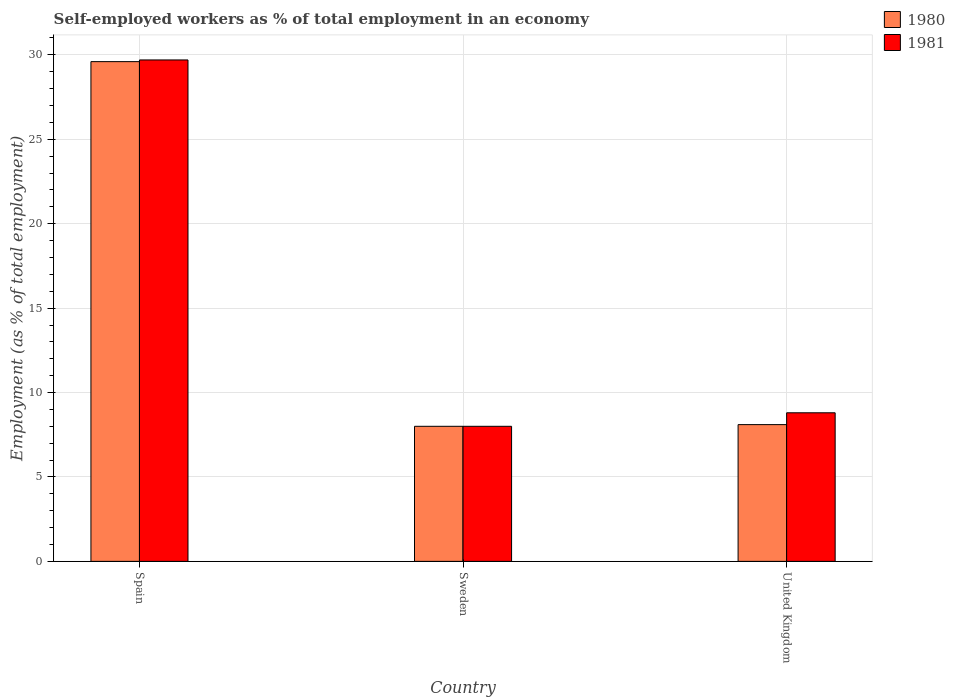Are the number of bars on each tick of the X-axis equal?
Offer a very short reply. Yes. How many bars are there on the 3rd tick from the left?
Your answer should be very brief. 2. What is the label of the 3rd group of bars from the left?
Offer a terse response. United Kingdom. What is the percentage of self-employed workers in 1981 in Spain?
Make the answer very short. 29.7. Across all countries, what is the maximum percentage of self-employed workers in 1980?
Give a very brief answer. 29.6. In which country was the percentage of self-employed workers in 1981 maximum?
Provide a short and direct response. Spain. In which country was the percentage of self-employed workers in 1980 minimum?
Make the answer very short. Sweden. What is the total percentage of self-employed workers in 1980 in the graph?
Your answer should be very brief. 45.7. What is the difference between the percentage of self-employed workers in 1981 in Sweden and that in United Kingdom?
Make the answer very short. -0.8. What is the difference between the percentage of self-employed workers in 1980 in Sweden and the percentage of self-employed workers in 1981 in United Kingdom?
Keep it short and to the point. -0.8. What is the average percentage of self-employed workers in 1980 per country?
Offer a terse response. 15.23. What is the difference between the percentage of self-employed workers of/in 1981 and percentage of self-employed workers of/in 1980 in United Kingdom?
Your response must be concise. 0.7. In how many countries, is the percentage of self-employed workers in 1980 greater than 19 %?
Your response must be concise. 1. What is the ratio of the percentage of self-employed workers in 1980 in Spain to that in United Kingdom?
Give a very brief answer. 3.65. Is the percentage of self-employed workers in 1981 in Sweden less than that in United Kingdom?
Give a very brief answer. Yes. Is the difference between the percentage of self-employed workers in 1981 in Sweden and United Kingdom greater than the difference between the percentage of self-employed workers in 1980 in Sweden and United Kingdom?
Ensure brevity in your answer.  No. What is the difference between the highest and the second highest percentage of self-employed workers in 1980?
Your response must be concise. 0.1. What is the difference between the highest and the lowest percentage of self-employed workers in 1980?
Provide a succinct answer. 21.6. Is the sum of the percentage of self-employed workers in 1981 in Sweden and United Kingdom greater than the maximum percentage of self-employed workers in 1980 across all countries?
Ensure brevity in your answer.  No. What does the 1st bar from the left in Spain represents?
Provide a succinct answer. 1980. How many countries are there in the graph?
Keep it short and to the point. 3. Does the graph contain any zero values?
Give a very brief answer. No. Does the graph contain grids?
Ensure brevity in your answer.  Yes. How many legend labels are there?
Keep it short and to the point. 2. What is the title of the graph?
Ensure brevity in your answer.  Self-employed workers as % of total employment in an economy. What is the label or title of the Y-axis?
Your response must be concise. Employment (as % of total employment). What is the Employment (as % of total employment) in 1980 in Spain?
Make the answer very short. 29.6. What is the Employment (as % of total employment) of 1981 in Spain?
Make the answer very short. 29.7. What is the Employment (as % of total employment) in 1981 in Sweden?
Your response must be concise. 8. What is the Employment (as % of total employment) in 1980 in United Kingdom?
Your response must be concise. 8.1. What is the Employment (as % of total employment) in 1981 in United Kingdom?
Offer a very short reply. 8.8. Across all countries, what is the maximum Employment (as % of total employment) in 1980?
Offer a terse response. 29.6. Across all countries, what is the maximum Employment (as % of total employment) of 1981?
Your answer should be compact. 29.7. Across all countries, what is the minimum Employment (as % of total employment) of 1980?
Offer a very short reply. 8. Across all countries, what is the minimum Employment (as % of total employment) in 1981?
Ensure brevity in your answer.  8. What is the total Employment (as % of total employment) in 1980 in the graph?
Provide a succinct answer. 45.7. What is the total Employment (as % of total employment) of 1981 in the graph?
Offer a terse response. 46.5. What is the difference between the Employment (as % of total employment) of 1980 in Spain and that in Sweden?
Provide a short and direct response. 21.6. What is the difference between the Employment (as % of total employment) in 1981 in Spain and that in Sweden?
Your answer should be very brief. 21.7. What is the difference between the Employment (as % of total employment) of 1981 in Spain and that in United Kingdom?
Offer a terse response. 20.9. What is the difference between the Employment (as % of total employment) of 1980 in Sweden and that in United Kingdom?
Your answer should be very brief. -0.1. What is the difference between the Employment (as % of total employment) in 1981 in Sweden and that in United Kingdom?
Provide a succinct answer. -0.8. What is the difference between the Employment (as % of total employment) of 1980 in Spain and the Employment (as % of total employment) of 1981 in Sweden?
Provide a succinct answer. 21.6. What is the difference between the Employment (as % of total employment) of 1980 in Spain and the Employment (as % of total employment) of 1981 in United Kingdom?
Ensure brevity in your answer.  20.8. What is the average Employment (as % of total employment) in 1980 per country?
Offer a very short reply. 15.23. What is the difference between the Employment (as % of total employment) of 1980 and Employment (as % of total employment) of 1981 in Spain?
Your response must be concise. -0.1. What is the ratio of the Employment (as % of total employment) in 1981 in Spain to that in Sweden?
Keep it short and to the point. 3.71. What is the ratio of the Employment (as % of total employment) in 1980 in Spain to that in United Kingdom?
Keep it short and to the point. 3.65. What is the ratio of the Employment (as % of total employment) in 1981 in Spain to that in United Kingdom?
Your response must be concise. 3.38. What is the difference between the highest and the second highest Employment (as % of total employment) in 1981?
Provide a short and direct response. 20.9. What is the difference between the highest and the lowest Employment (as % of total employment) of 1980?
Your response must be concise. 21.6. What is the difference between the highest and the lowest Employment (as % of total employment) of 1981?
Give a very brief answer. 21.7. 